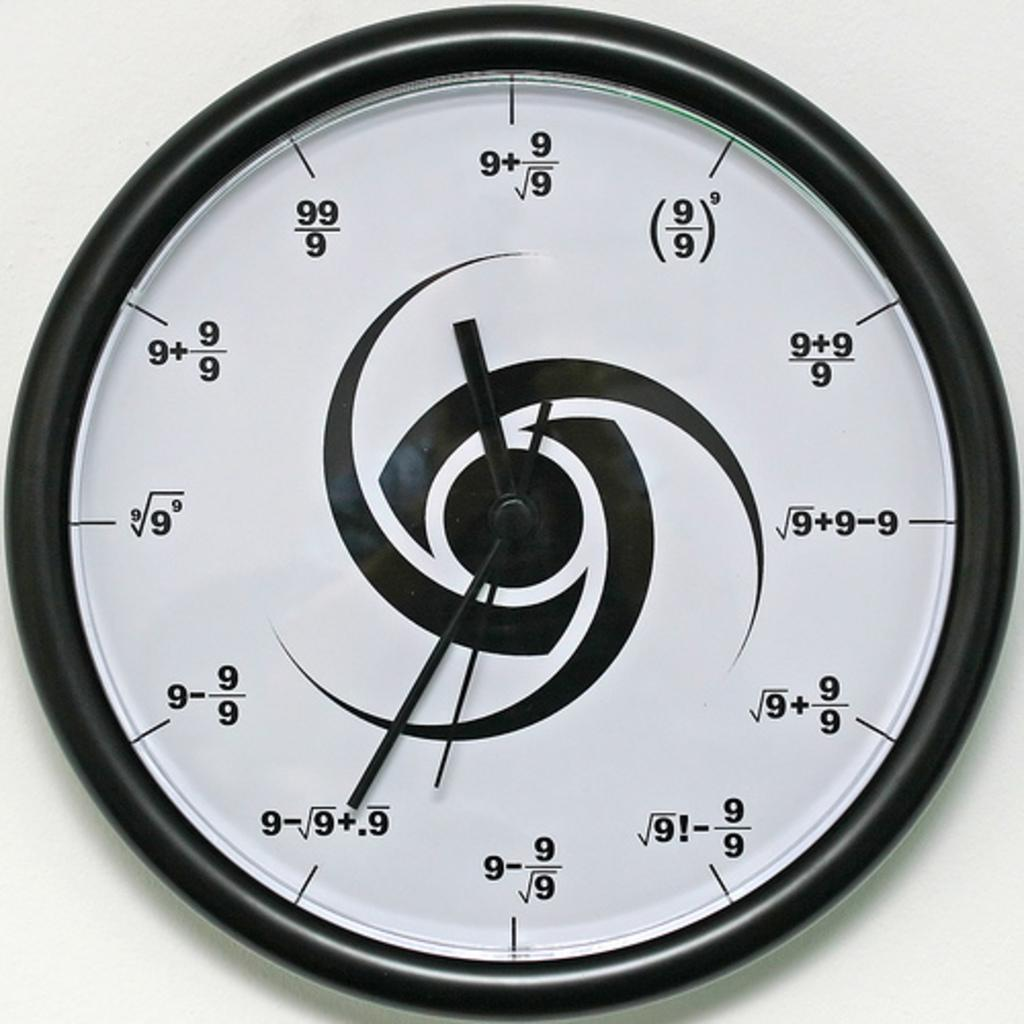What object in the image is used for telling time? There is a wall clock in the image that is used for telling time. What color is the background of the image? The background of the image is white. What type of train can be seen in the image? There is no train present in the image; it only features a wall clock and a white background. 